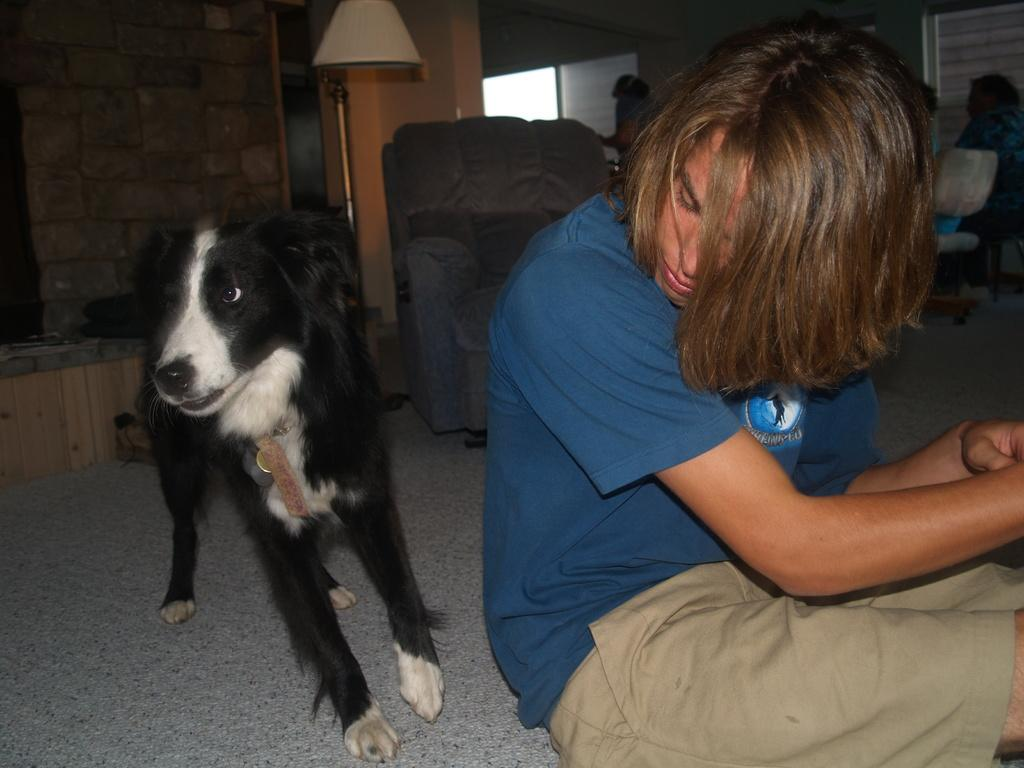How many people are in the image? There are persons in the image, but the exact number cannot be determined from the provided facts. What type of animal is in the image? There is a dog in the image. What is on the floor in the image? There are objects on the floor in the image. What can be seen on the wall in the image? There is a wall with windows in the image. What type of furniture is in the image? There are chairs in the image. What type of hen is depicted in the religious scene in the image? There is no hen or religious scene present in the image. What arithmetic problem is being solved by the persons in the image? There is no arithmetic problem being solved by the persons in the image. 